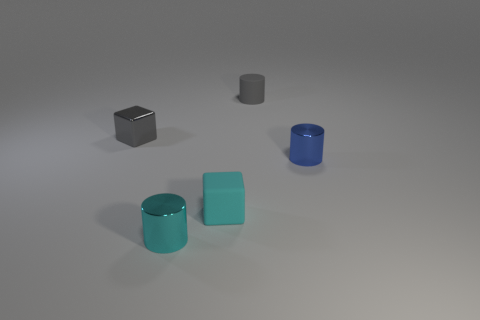Add 5 cyan things. How many objects exist? 10 Subtract all cylinders. How many objects are left? 2 Add 2 cyan matte objects. How many cyan matte objects are left? 3 Add 5 small cylinders. How many small cylinders exist? 8 Subtract 0 purple cylinders. How many objects are left? 5 Subtract all tiny purple cylinders. Subtract all tiny cyan things. How many objects are left? 3 